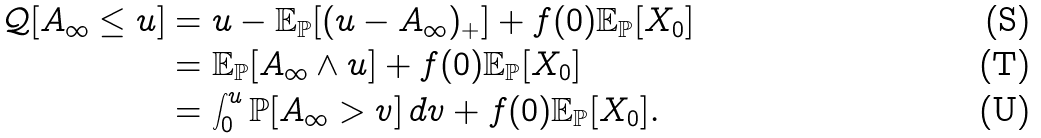<formula> <loc_0><loc_0><loc_500><loc_500>\mathcal { Q } [ A _ { \infty } \leq u ] & = u - \mathbb { E } _ { \mathbb { P } } [ ( u - A _ { \infty } ) _ { + } ] + f ( 0 ) \mathbb { E } _ { \mathbb { P } } [ X _ { 0 } ] \\ & = \mathbb { E } _ { \mathbb { P } } [ A _ { \infty } \wedge u ] + f ( 0 ) \mathbb { E } _ { \mathbb { P } } [ X _ { 0 } ] \\ & = \int _ { 0 } ^ { u } \mathbb { P } [ A _ { \infty } > v ] \, d v + f ( 0 ) \mathbb { E } _ { \mathbb { P } } [ X _ { 0 } ] .</formula> 